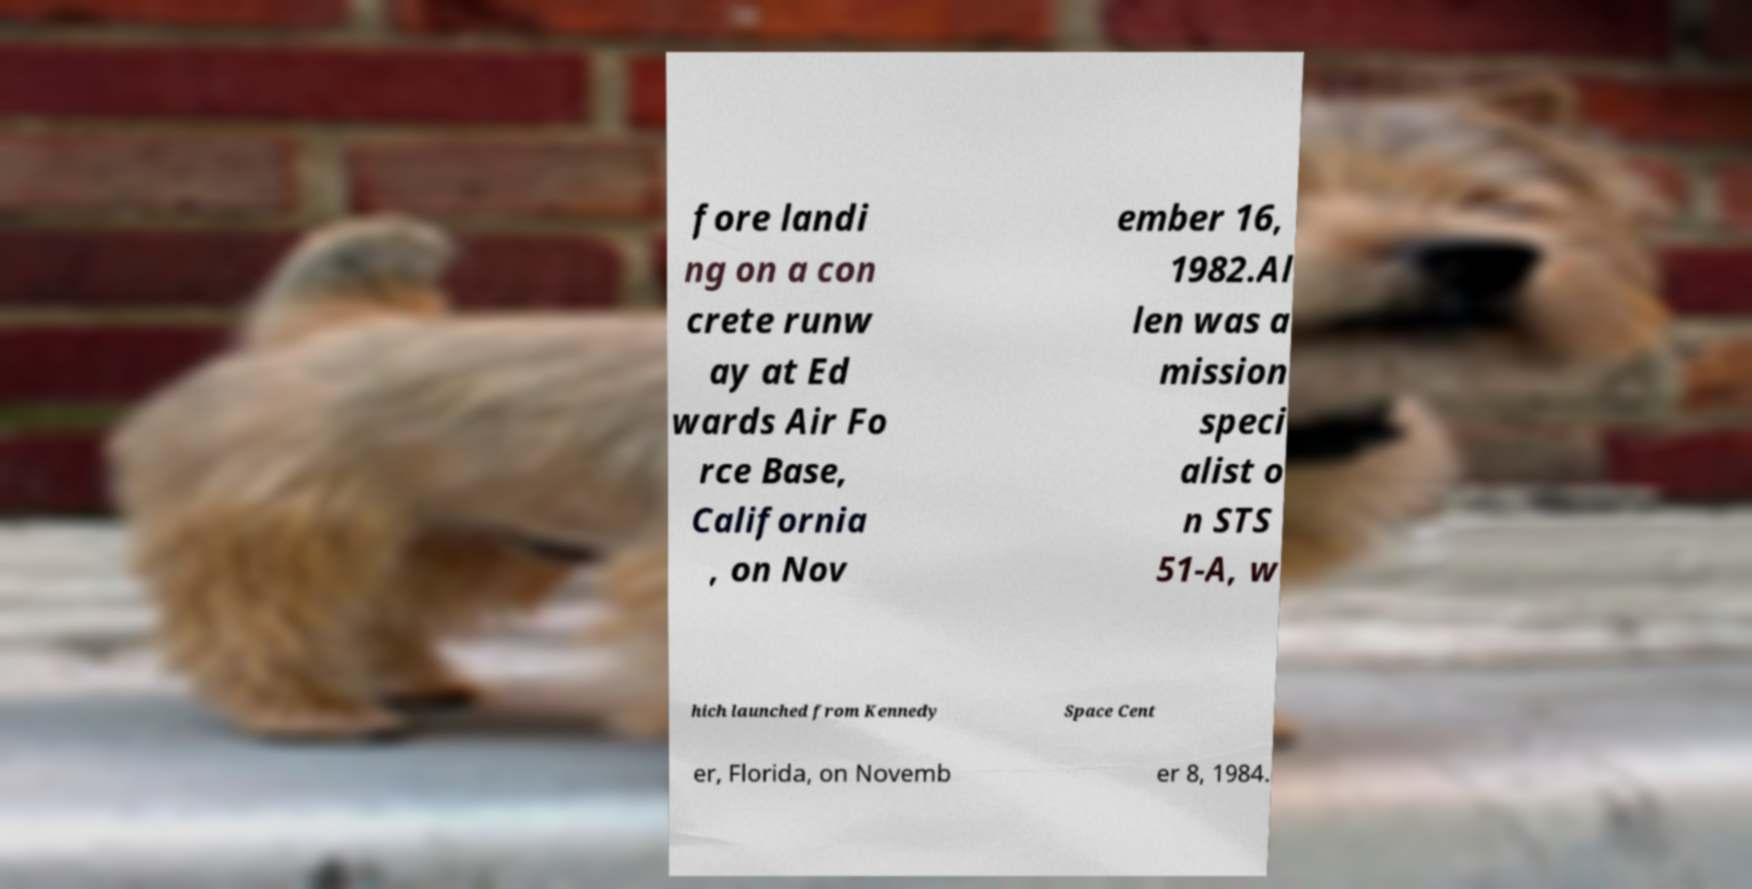Can you read and provide the text displayed in the image?This photo seems to have some interesting text. Can you extract and type it out for me? fore landi ng on a con crete runw ay at Ed wards Air Fo rce Base, California , on Nov ember 16, 1982.Al len was a mission speci alist o n STS 51-A, w hich launched from Kennedy Space Cent er, Florida, on Novemb er 8, 1984. 